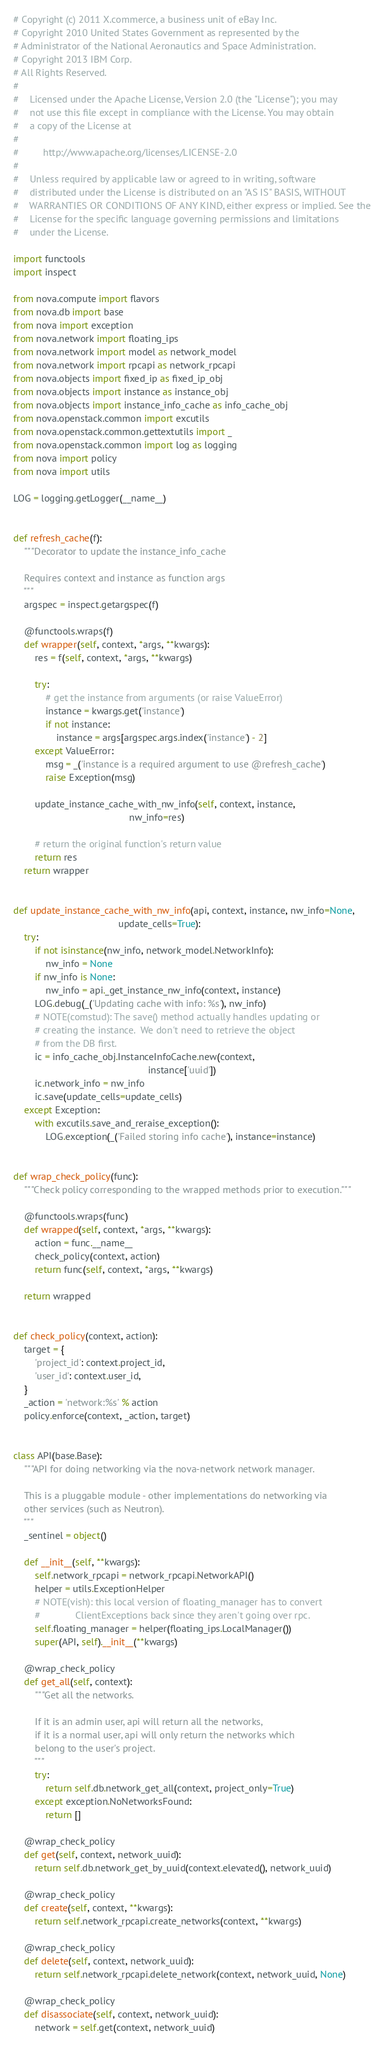Convert code to text. <code><loc_0><loc_0><loc_500><loc_500><_Python_># Copyright (c) 2011 X.commerce, a business unit of eBay Inc.
# Copyright 2010 United States Government as represented by the
# Administrator of the National Aeronautics and Space Administration.
# Copyright 2013 IBM Corp.
# All Rights Reserved.
#
#    Licensed under the Apache License, Version 2.0 (the "License"); you may
#    not use this file except in compliance with the License. You may obtain
#    a copy of the License at
#
#         http://www.apache.org/licenses/LICENSE-2.0
#
#    Unless required by applicable law or agreed to in writing, software
#    distributed under the License is distributed on an "AS IS" BASIS, WITHOUT
#    WARRANTIES OR CONDITIONS OF ANY KIND, either express or implied. See the
#    License for the specific language governing permissions and limitations
#    under the License.

import functools
import inspect

from nova.compute import flavors
from nova.db import base
from nova import exception
from nova.network import floating_ips
from nova.network import model as network_model
from nova.network import rpcapi as network_rpcapi
from nova.objects import fixed_ip as fixed_ip_obj
from nova.objects import instance as instance_obj
from nova.objects import instance_info_cache as info_cache_obj
from nova.openstack.common import excutils
from nova.openstack.common.gettextutils import _
from nova.openstack.common import log as logging
from nova import policy
from nova import utils

LOG = logging.getLogger(__name__)


def refresh_cache(f):
    """Decorator to update the instance_info_cache

    Requires context and instance as function args
    """
    argspec = inspect.getargspec(f)

    @functools.wraps(f)
    def wrapper(self, context, *args, **kwargs):
        res = f(self, context, *args, **kwargs)

        try:
            # get the instance from arguments (or raise ValueError)
            instance = kwargs.get('instance')
            if not instance:
                instance = args[argspec.args.index('instance') - 2]
        except ValueError:
            msg = _('instance is a required argument to use @refresh_cache')
            raise Exception(msg)

        update_instance_cache_with_nw_info(self, context, instance,
                                           nw_info=res)

        # return the original function's return value
        return res
    return wrapper


def update_instance_cache_with_nw_info(api, context, instance, nw_info=None,
                                       update_cells=True):
    try:
        if not isinstance(nw_info, network_model.NetworkInfo):
            nw_info = None
        if nw_info is None:
            nw_info = api._get_instance_nw_info(context, instance)
        LOG.debug(_('Updating cache with info: %s'), nw_info)
        # NOTE(comstud): The save() method actually handles updating or
        # creating the instance.  We don't need to retrieve the object
        # from the DB first.
        ic = info_cache_obj.InstanceInfoCache.new(context,
                                                  instance['uuid'])
        ic.network_info = nw_info
        ic.save(update_cells=update_cells)
    except Exception:
        with excutils.save_and_reraise_exception():
            LOG.exception(_('Failed storing info cache'), instance=instance)


def wrap_check_policy(func):
    """Check policy corresponding to the wrapped methods prior to execution."""

    @functools.wraps(func)
    def wrapped(self, context, *args, **kwargs):
        action = func.__name__
        check_policy(context, action)
        return func(self, context, *args, **kwargs)

    return wrapped


def check_policy(context, action):
    target = {
        'project_id': context.project_id,
        'user_id': context.user_id,
    }
    _action = 'network:%s' % action
    policy.enforce(context, _action, target)


class API(base.Base):
    """API for doing networking via the nova-network network manager.

    This is a pluggable module - other implementations do networking via
    other services (such as Neutron).
    """
    _sentinel = object()

    def __init__(self, **kwargs):
        self.network_rpcapi = network_rpcapi.NetworkAPI()
        helper = utils.ExceptionHelper
        # NOTE(vish): this local version of floating_manager has to convert
        #             ClientExceptions back since they aren't going over rpc.
        self.floating_manager = helper(floating_ips.LocalManager())
        super(API, self).__init__(**kwargs)

    @wrap_check_policy
    def get_all(self, context):
        """Get all the networks.

        If it is an admin user, api will return all the networks,
        if it is a normal user, api will only return the networks which
        belong to the user's project.
        """
        try:
            return self.db.network_get_all(context, project_only=True)
        except exception.NoNetworksFound:
            return []

    @wrap_check_policy
    def get(self, context, network_uuid):
        return self.db.network_get_by_uuid(context.elevated(), network_uuid)

    @wrap_check_policy
    def create(self, context, **kwargs):
        return self.network_rpcapi.create_networks(context, **kwargs)

    @wrap_check_policy
    def delete(self, context, network_uuid):
        return self.network_rpcapi.delete_network(context, network_uuid, None)

    @wrap_check_policy
    def disassociate(self, context, network_uuid):
        network = self.get(context, network_uuid)</code> 